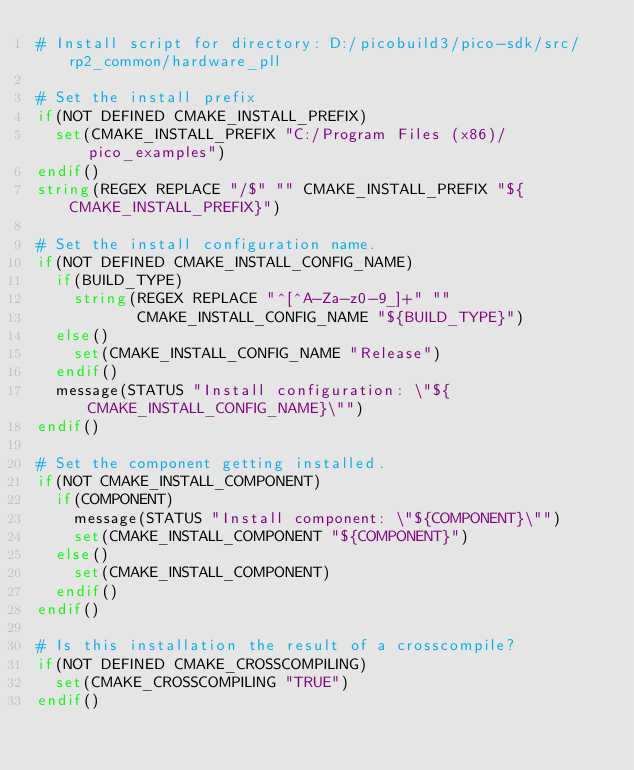<code> <loc_0><loc_0><loc_500><loc_500><_CMake_># Install script for directory: D:/picobuild3/pico-sdk/src/rp2_common/hardware_pll

# Set the install prefix
if(NOT DEFINED CMAKE_INSTALL_PREFIX)
  set(CMAKE_INSTALL_PREFIX "C:/Program Files (x86)/pico_examples")
endif()
string(REGEX REPLACE "/$" "" CMAKE_INSTALL_PREFIX "${CMAKE_INSTALL_PREFIX}")

# Set the install configuration name.
if(NOT DEFINED CMAKE_INSTALL_CONFIG_NAME)
  if(BUILD_TYPE)
    string(REGEX REPLACE "^[^A-Za-z0-9_]+" ""
           CMAKE_INSTALL_CONFIG_NAME "${BUILD_TYPE}")
  else()
    set(CMAKE_INSTALL_CONFIG_NAME "Release")
  endif()
  message(STATUS "Install configuration: \"${CMAKE_INSTALL_CONFIG_NAME}\"")
endif()

# Set the component getting installed.
if(NOT CMAKE_INSTALL_COMPONENT)
  if(COMPONENT)
    message(STATUS "Install component: \"${COMPONENT}\"")
    set(CMAKE_INSTALL_COMPONENT "${COMPONENT}")
  else()
    set(CMAKE_INSTALL_COMPONENT)
  endif()
endif()

# Is this installation the result of a crosscompile?
if(NOT DEFINED CMAKE_CROSSCOMPILING)
  set(CMAKE_CROSSCOMPILING "TRUE")
endif()

</code> 